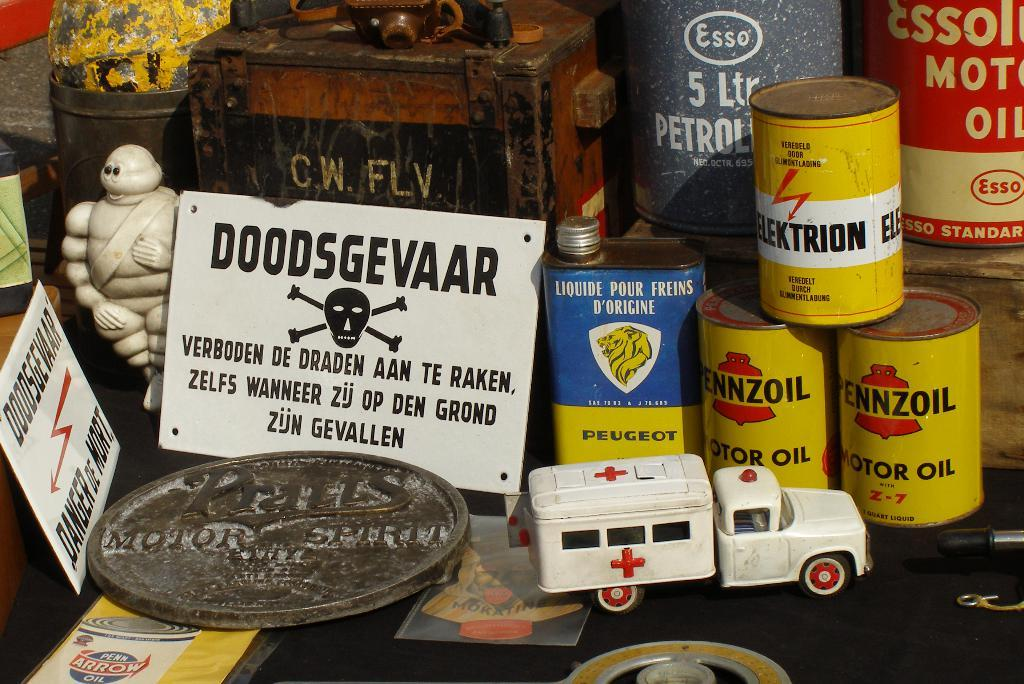<image>
Write a terse but informative summary of the picture. A display of goods with Castor Oil on display. 